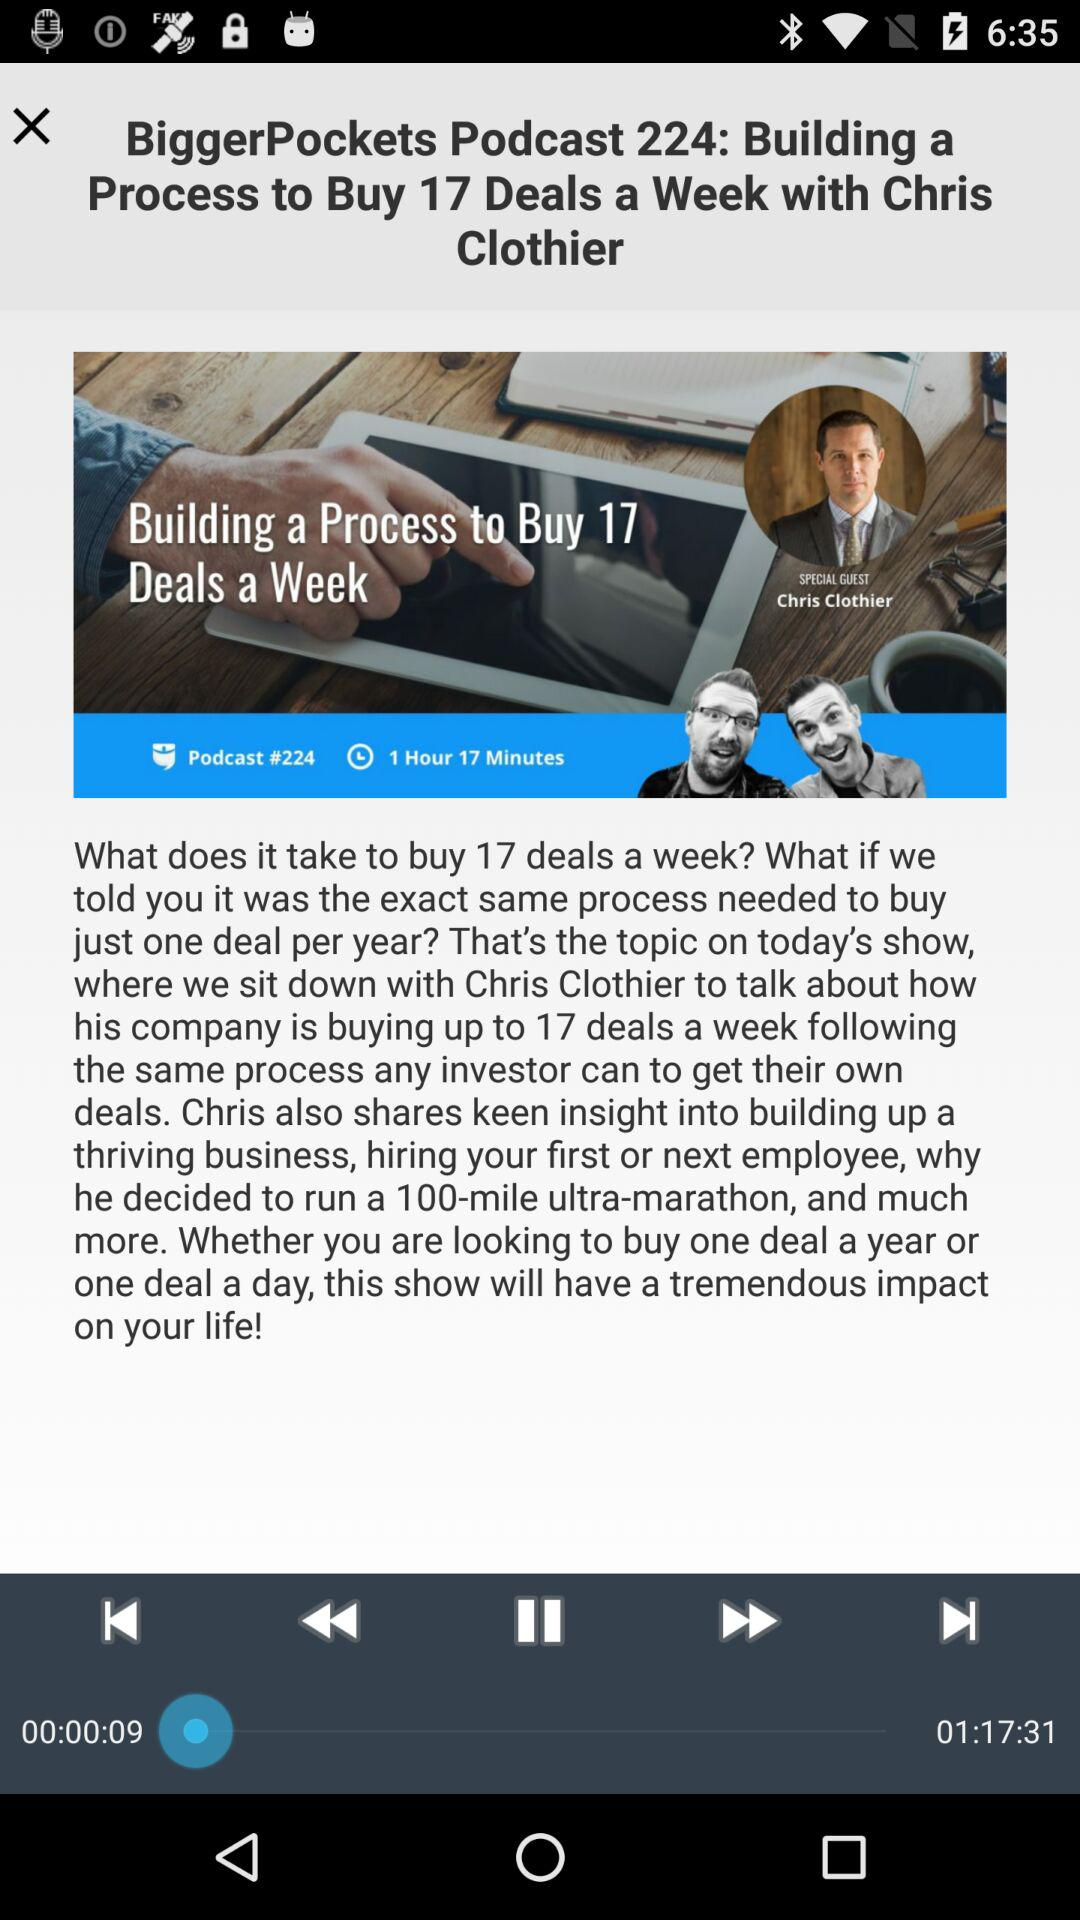How long is this video? The video is 1 hour, 17 minutes, and 31 seconds long. 